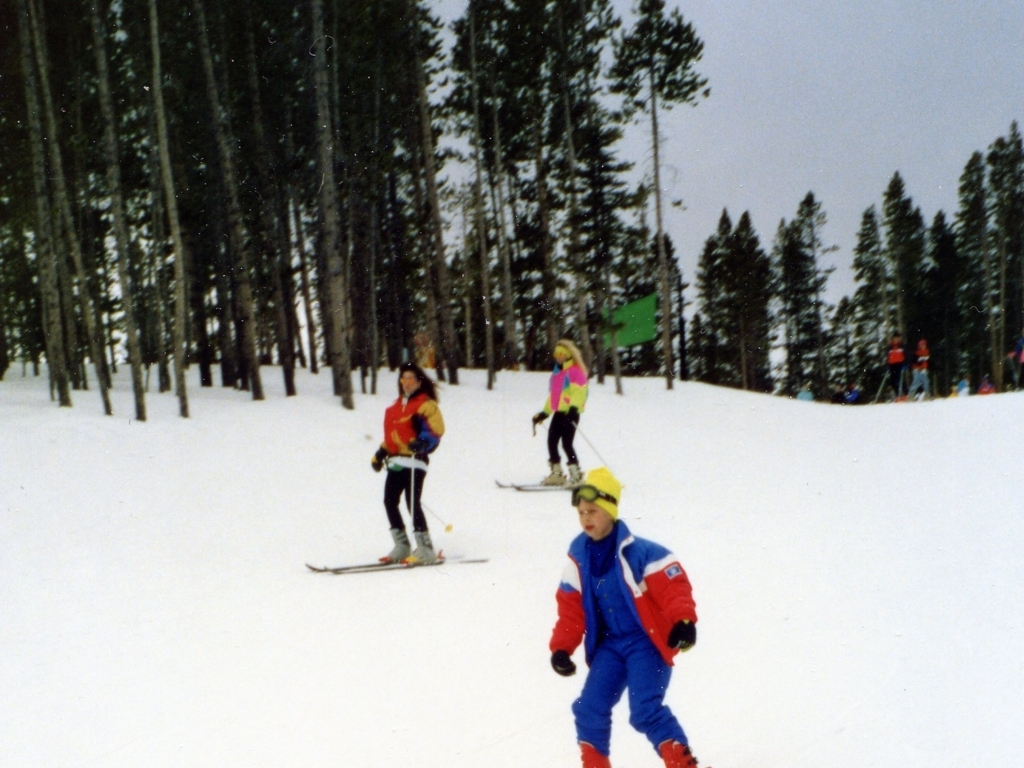Can you describe the attire of the people in the image and why it’s appropriate for the activity? Certainly! The skiers are wearing insulated jackets and pants, which are essential for staying warm and dry in snowy, cold conditions. Brightly colored attires, like those seen here, improve visibility on the slopes, which is important for safety. 